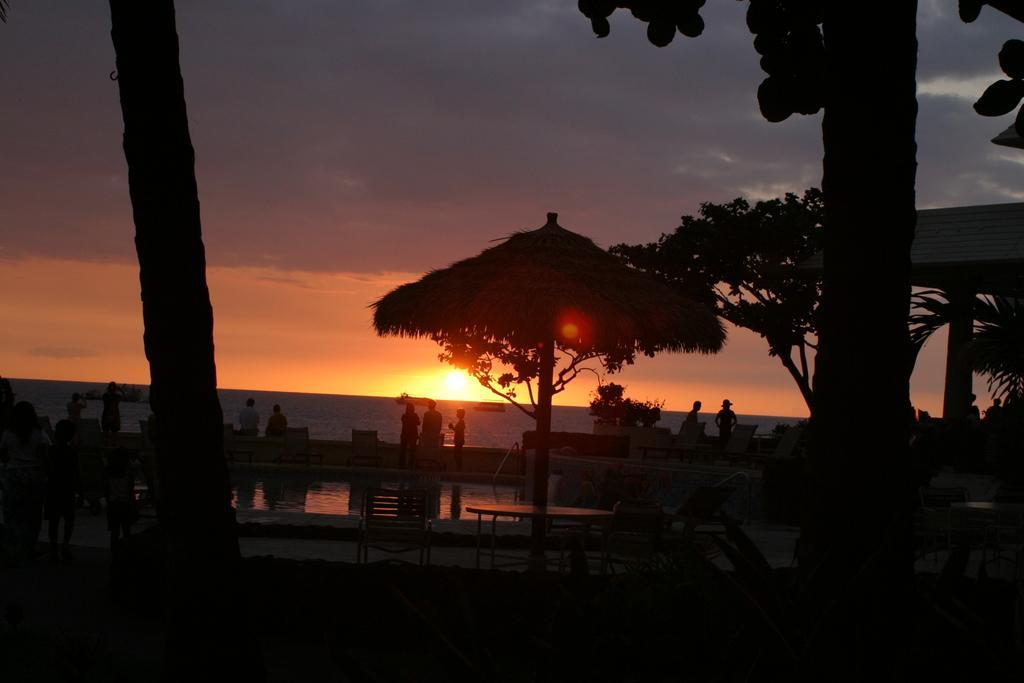Can you describe this image briefly? In this picture we can see trees, a table, chairs in the front, there are some people standing in the middle, in the background it might be water, we can see the Sun and the sky at the top of the picture. 